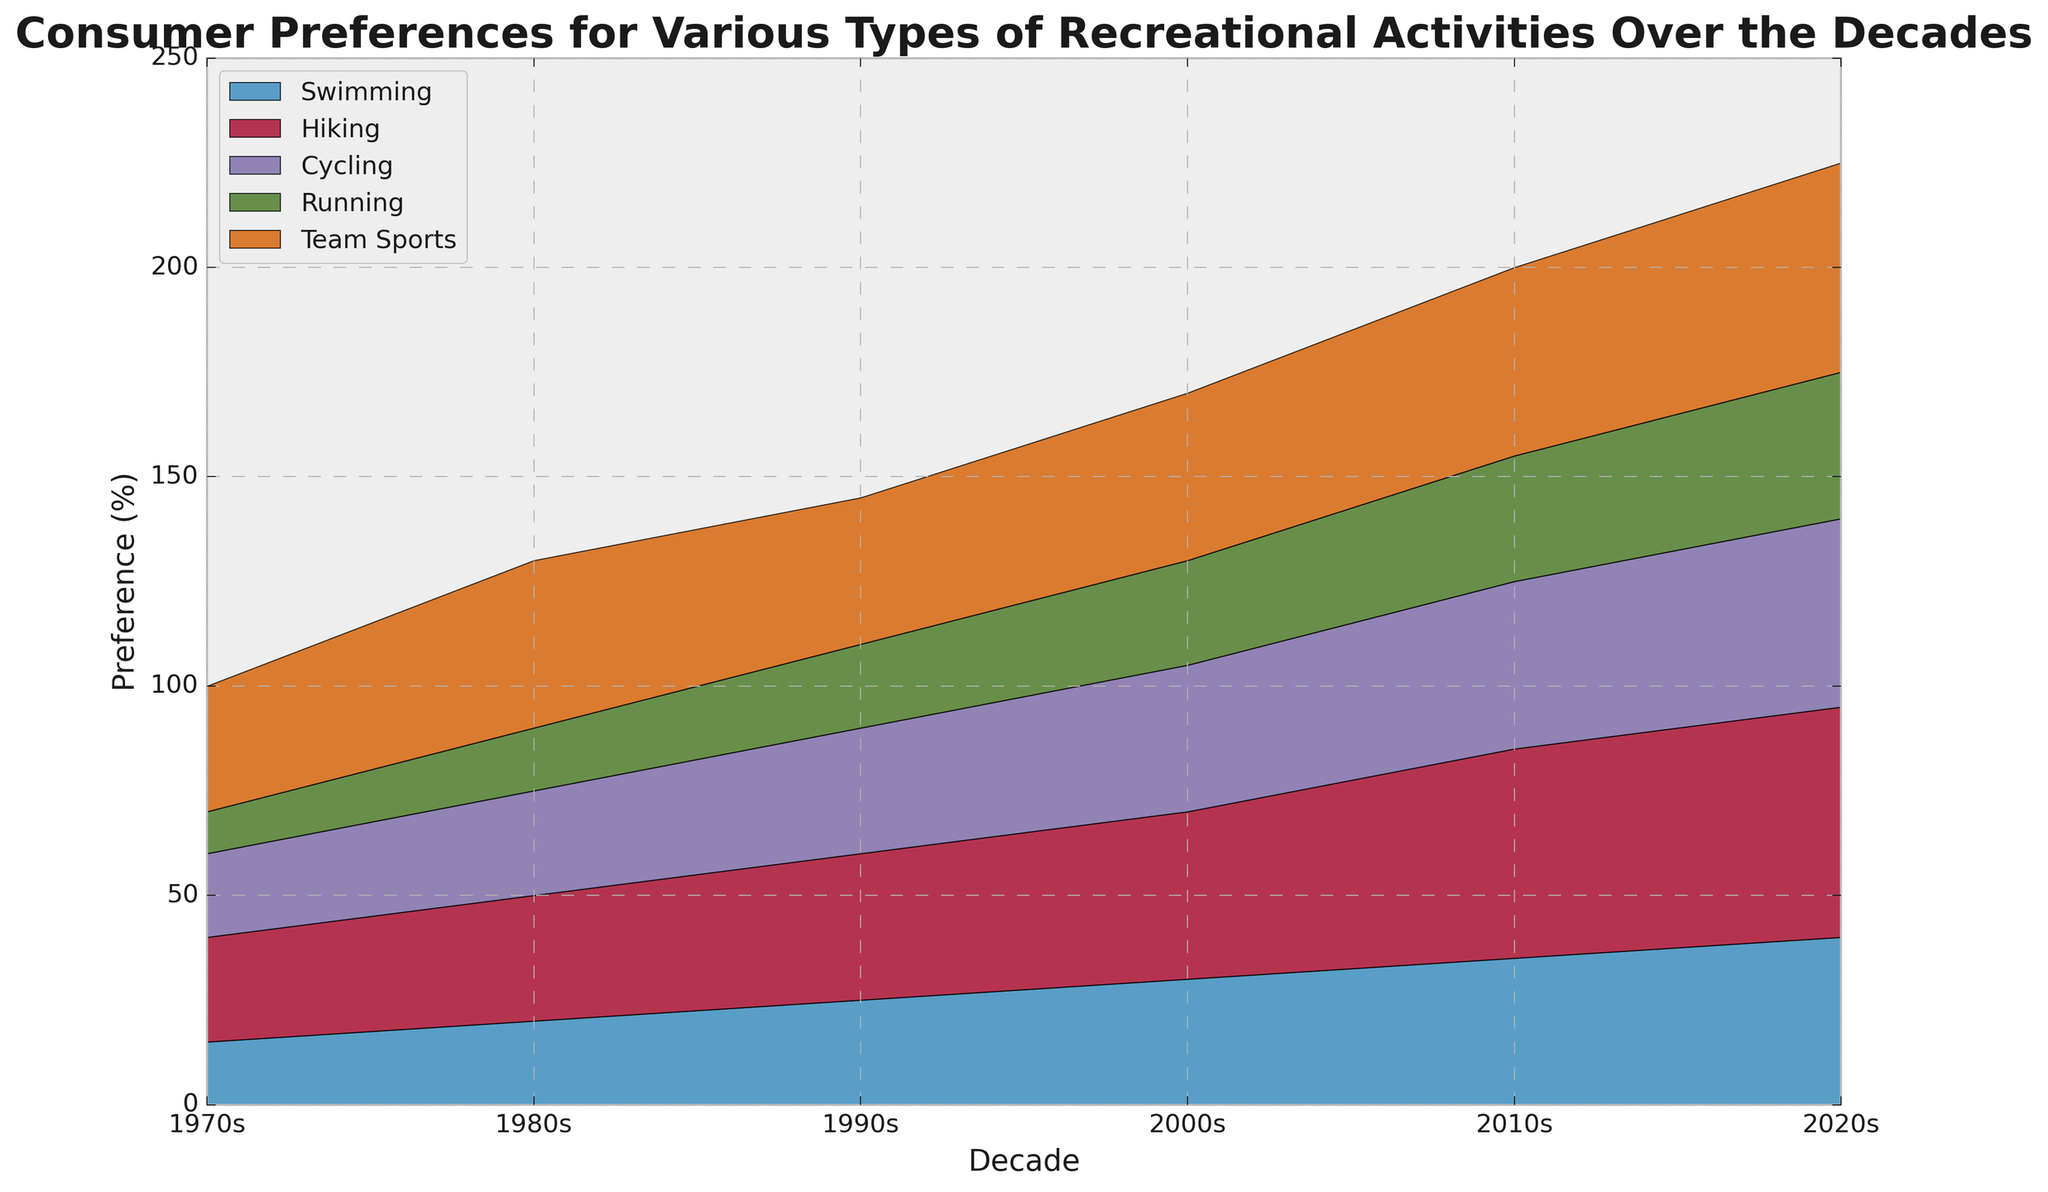How has the preference for swimming changed from the 1970s to the 2020s? Look at the preference data for swimming. In the 1970s, it was 15%, and in the 2020s, it increased to 40%.
Answer: It increased by 25% Which recreational activity had the highest preference in the 2020s? Observe the heights of the areas in the 2020s. Team Sports have the highest preference in the 2020s at 50%.
Answer: Team Sports What is the total preference percentage for Hiking and Cycling in the 2010s? Sum up the preference percentages for Hiking and Cycling in the 2010s. Hiking is 50% and Cycling is 40%, so 50 + 40 = 90%.
Answer: 90% Compare the growth of preference for Hiking and Running from the 1970s to the 2020s. Which grew more? Hiking grew from 25% in the 1970s to 55% in the 2020s, an increase of 30%. Running grew from 10% in the 1970s to 35% in the 2020s, an increase of 25%.
Answer: Hiking grew more During which decade did all recreational activities see the most significant increase in preferences? Examine the decade-to-decade changes and sum the increases for all activities. The 2010s see significant increases for most activities: Swimming (5%), Hiking (5%), Cycling (5%), Running (5%), Team Sports (5%).
Answer: 2010s What is the average preference for Team Sports across all decades? Sum the preferences for Team Sports across each decade and then divide by the number of decades. (30% + 40% + 35% + 40% + 45% + 50%) / 6 = 240% / 6 = 40%.
Answer: 40% Which activity showed the least change in preference between the 1980s to the 2000s? Compare the changes for each activity. Swimming: 30% - 20% = 10%, Hiking: 40% - 30% = 10%, Cycling: 35% - 25% = 10%, Running: 25% - 15% = 10%, Team Sports: 40% - 40% = 0%.
Answer: Team Sports How did the preference for Cycling change in the 1990s compared to the previous decade? Look at the preference for Cycling in the 1980s (25%) and in the 1990s (30%). The change is 30% - 25% = 5%.
Answer: It increased by 5% What was the combined preference for Swimming, Cycling, and Running in the 1970s? Add the preference percentages for Swimming, Cycling, and Running in the 1970s. Swimming = 15%, Cycling = 20%, Running = 10%. So, 15 + 20 + 10 = 45%.
Answer: 45% Which activity had the highest increase in preference from the 2010s to the 2020s? Compare the increases for each activity from 2010s to 2020s. Swimming: 40% - 35% = 5%, Hiking: 55% - 50% = 5%, Cycling: 45% - 40% = 5%, Running: 35% - 30% = 5%, Team Sports: 50% - 45% = 5%. All activities increased by 5%.
Answer: All activities increased equally 